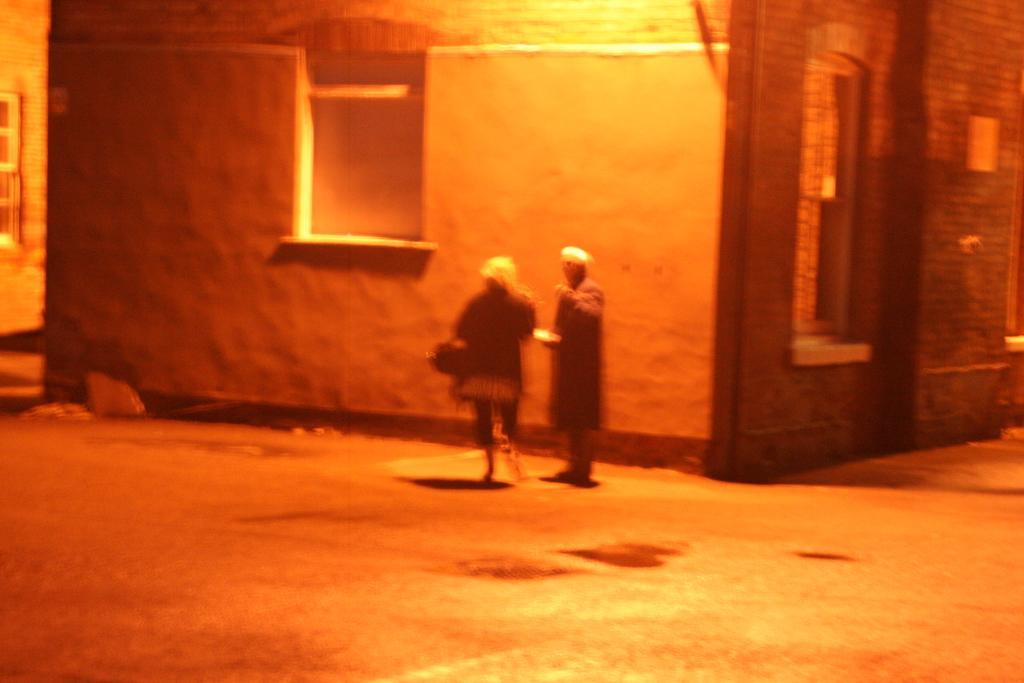Can you describe this image briefly? In this image I can see the dark picture in which I can see the ground, few persons standing on the ground and few buildings. I can see few windows of the buildings. 